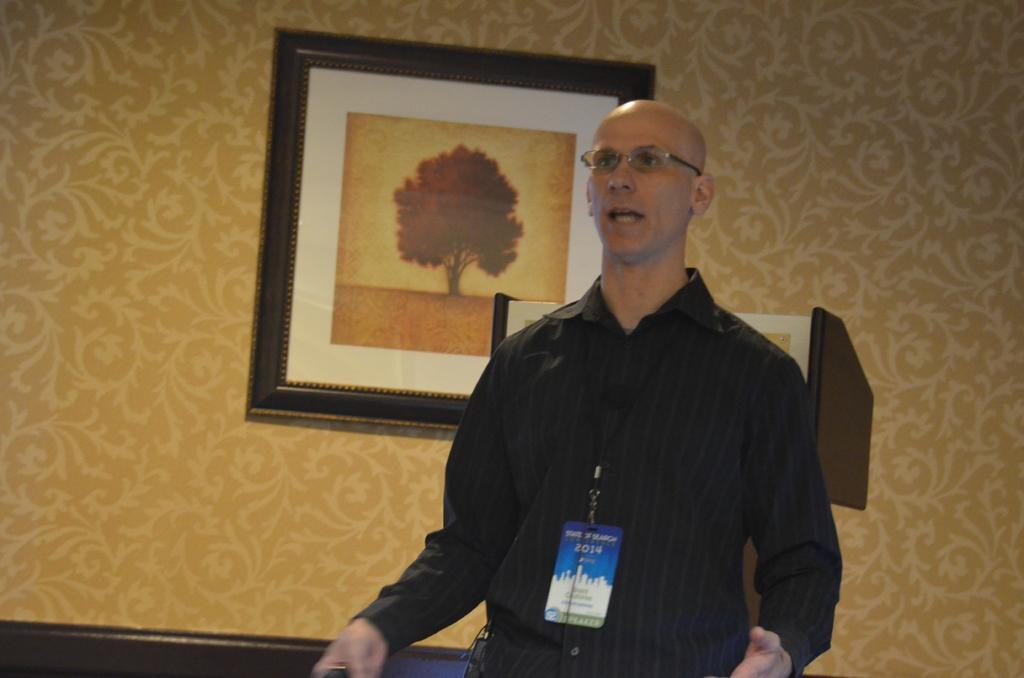What can be seen in the image? There is a person in the image. Can you describe the person's appearance? The person is wearing spectacles. Does the person have any identification in the image? Yes, the person has an ID card. What can be seen in the background of the image? There are photo frames on the wall in the background of the image. What type of prose is the person reading in the image? There is no indication in the image that the person is reading any prose. 